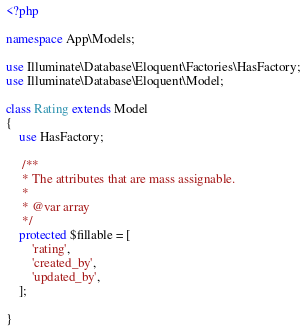<code> <loc_0><loc_0><loc_500><loc_500><_PHP_><?php

namespace App\Models;

use Illuminate\Database\Eloquent\Factories\HasFactory;
use Illuminate\Database\Eloquent\Model;

class Rating extends Model
{
    use HasFactory;

     /**
     * The attributes that are mass assignable.
     *
     * @var array
     */
    protected $fillable = [
        'rating',
        'created_by',
        'updated_by',
    ];

}
</code> 